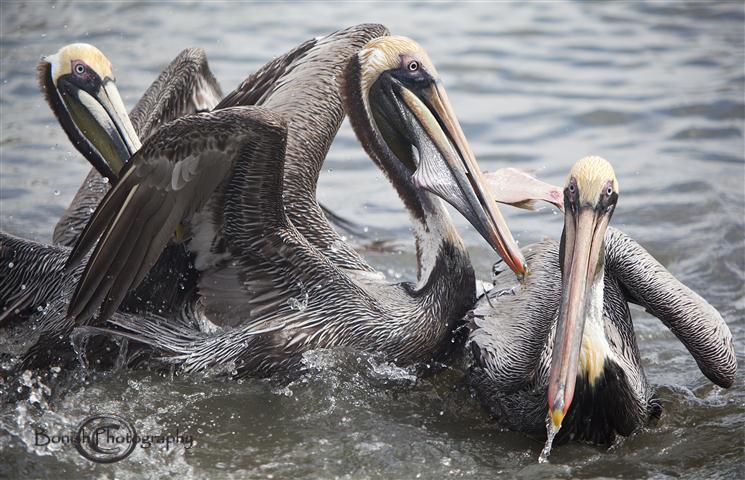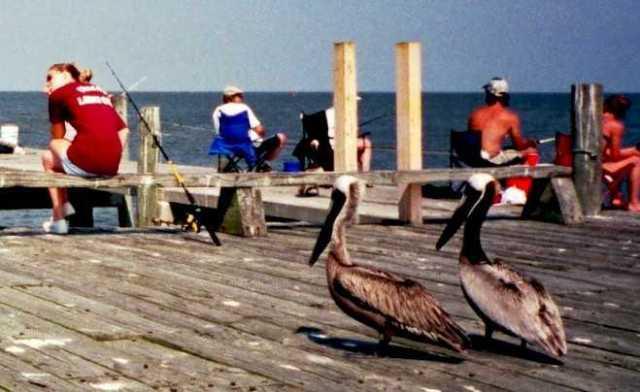The first image is the image on the left, the second image is the image on the right. Assess this claim about the two images: "At least one pelican is flying.". Correct or not? Answer yes or no. No. The first image is the image on the left, the second image is the image on the right. Considering the images on both sides, is "One image includes pelicans on a wooden pier, and the other image shows at least one pelican in the water." valid? Answer yes or no. Yes. 